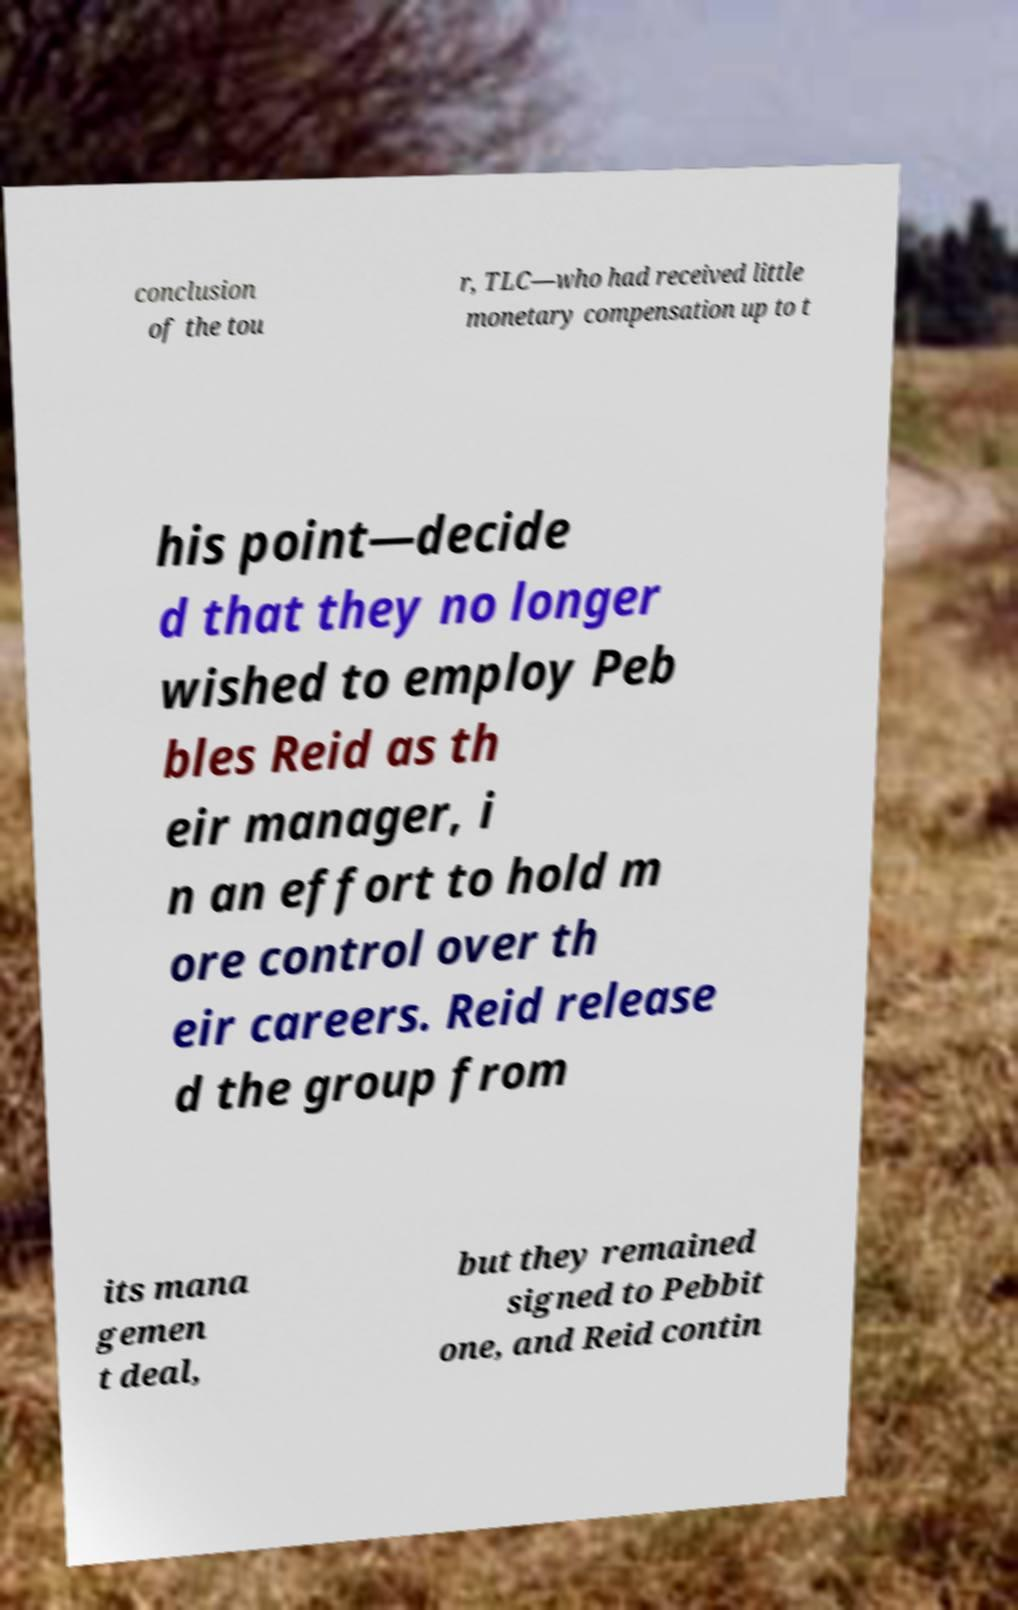Can you read and provide the text displayed in the image?This photo seems to have some interesting text. Can you extract and type it out for me? conclusion of the tou r, TLC—who had received little monetary compensation up to t his point—decide d that they no longer wished to employ Peb bles Reid as th eir manager, i n an effort to hold m ore control over th eir careers. Reid release d the group from its mana gemen t deal, but they remained signed to Pebbit one, and Reid contin 